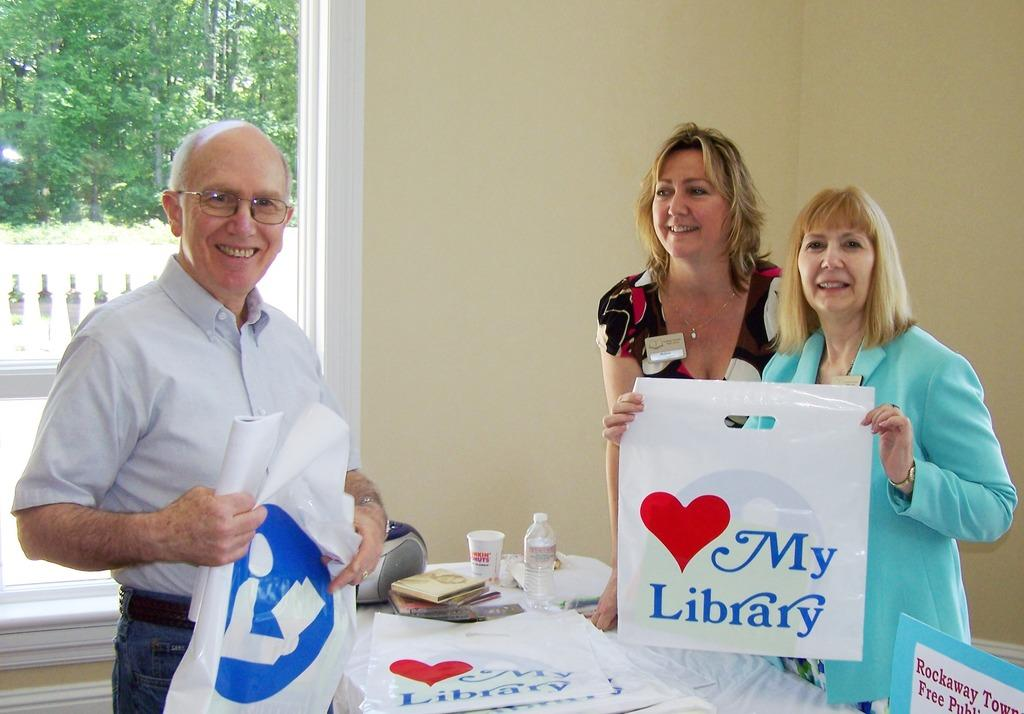<image>
Offer a succinct explanation of the picture presented. A man and two women are holding up white bags that say My Library. 